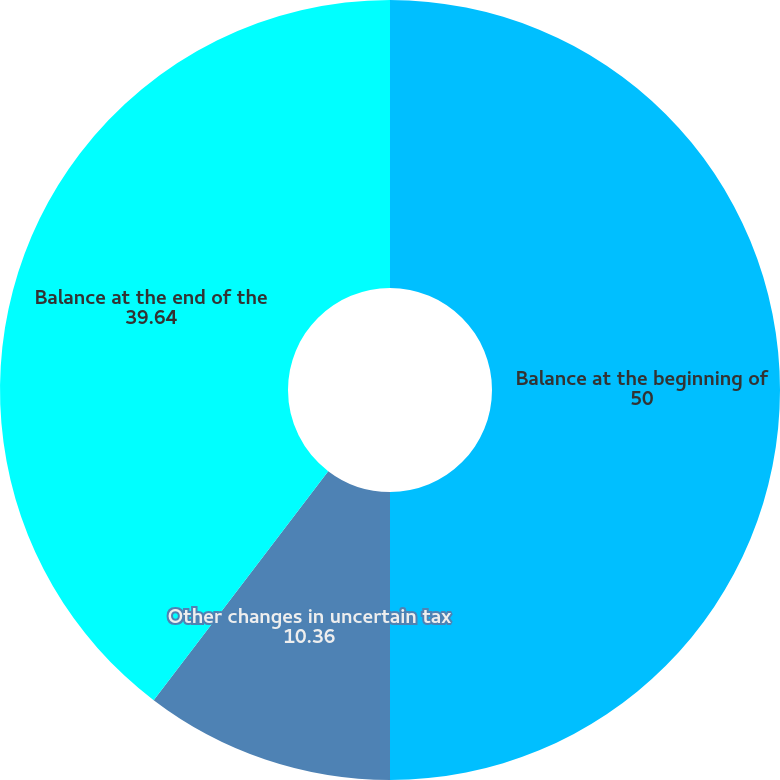<chart> <loc_0><loc_0><loc_500><loc_500><pie_chart><fcel>Balance at the beginning of<fcel>Other changes in uncertain tax<fcel>Balance at the end of the<nl><fcel>50.0%<fcel>10.36%<fcel>39.64%<nl></chart> 